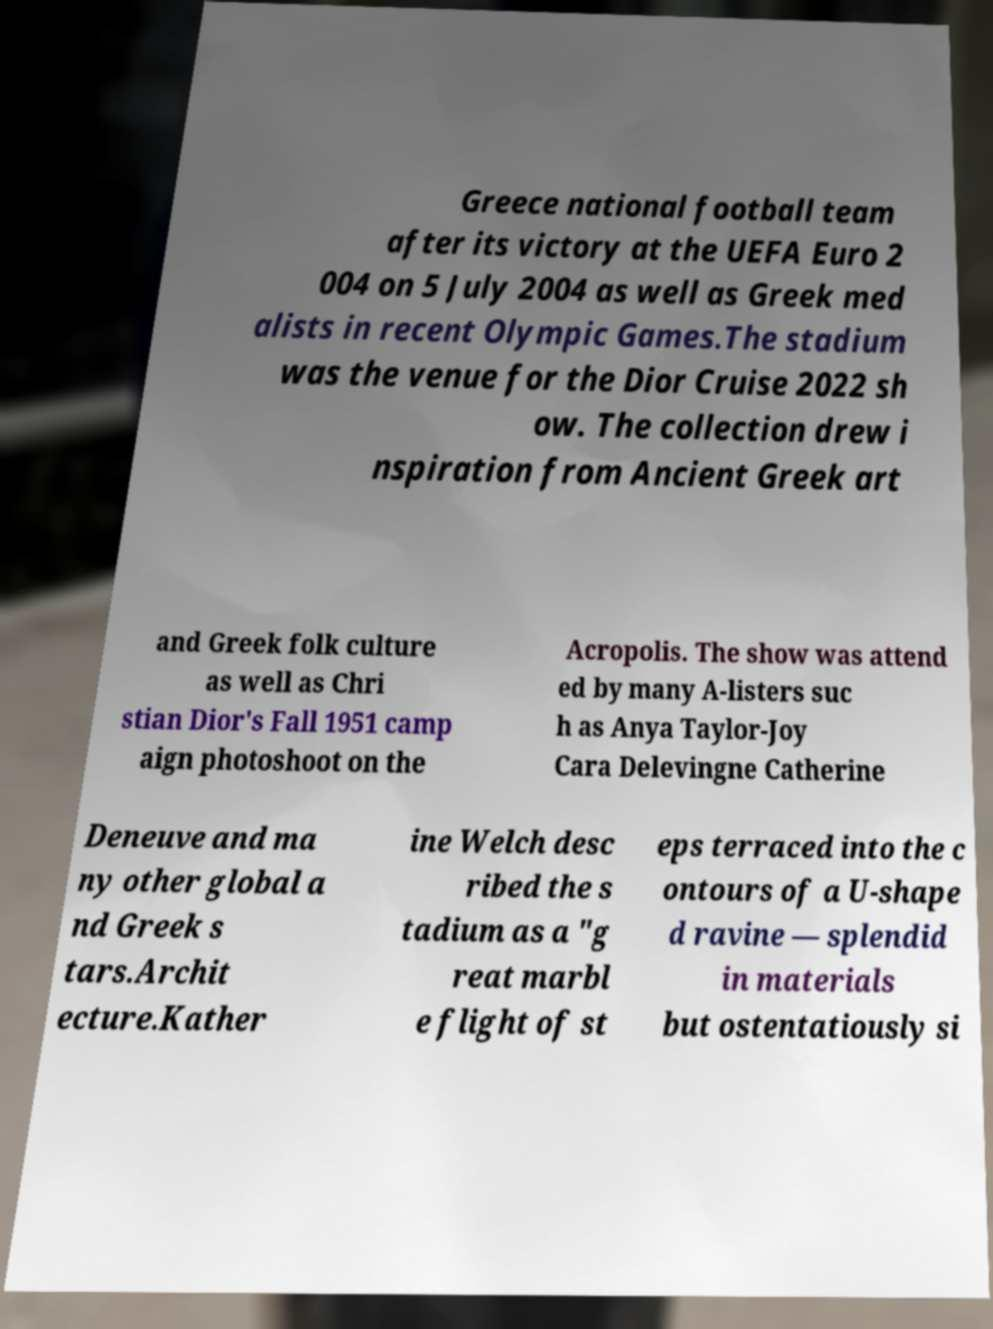I need the written content from this picture converted into text. Can you do that? Greece national football team after its victory at the UEFA Euro 2 004 on 5 July 2004 as well as Greek med alists in recent Olympic Games.The stadium was the venue for the Dior Cruise 2022 sh ow. The collection drew i nspiration from Ancient Greek art and Greek folk culture as well as Chri stian Dior's Fall 1951 camp aign photoshoot on the Acropolis. The show was attend ed by many A-listers suc h as Anya Taylor-Joy Cara Delevingne Catherine Deneuve and ma ny other global a nd Greek s tars.Archit ecture.Kather ine Welch desc ribed the s tadium as a "g reat marbl e flight of st eps terraced into the c ontours of a U-shape d ravine — splendid in materials but ostentatiously si 